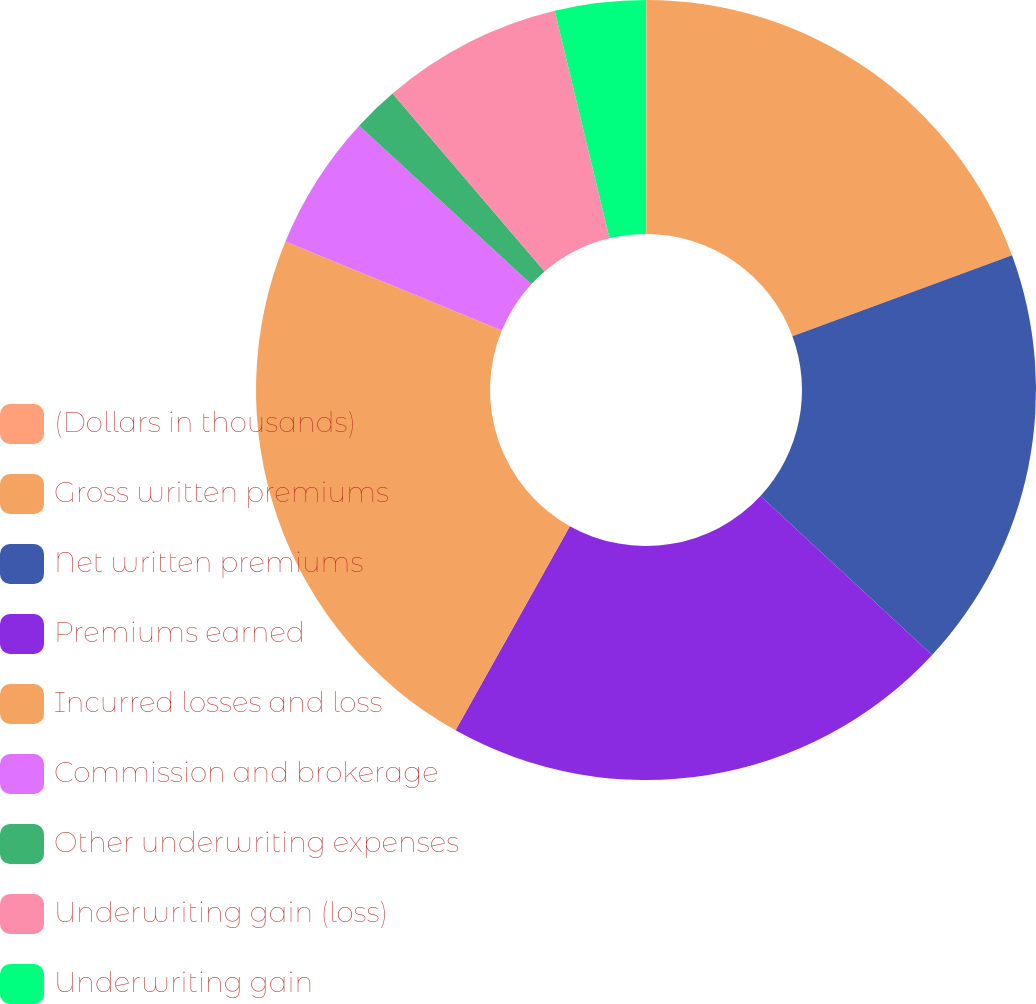<chart> <loc_0><loc_0><loc_500><loc_500><pie_chart><fcel>(Dollars in thousands)<fcel>Gross written premiums<fcel>Net written premiums<fcel>Premiums earned<fcel>Incurred losses and loss<fcel>Commission and brokerage<fcel>Other underwriting expenses<fcel>Underwriting gain (loss)<fcel>Underwriting gain<nl><fcel>0.03%<fcel>19.36%<fcel>17.5%<fcel>21.23%<fcel>23.1%<fcel>5.63%<fcel>1.89%<fcel>7.5%<fcel>3.76%<nl></chart> 